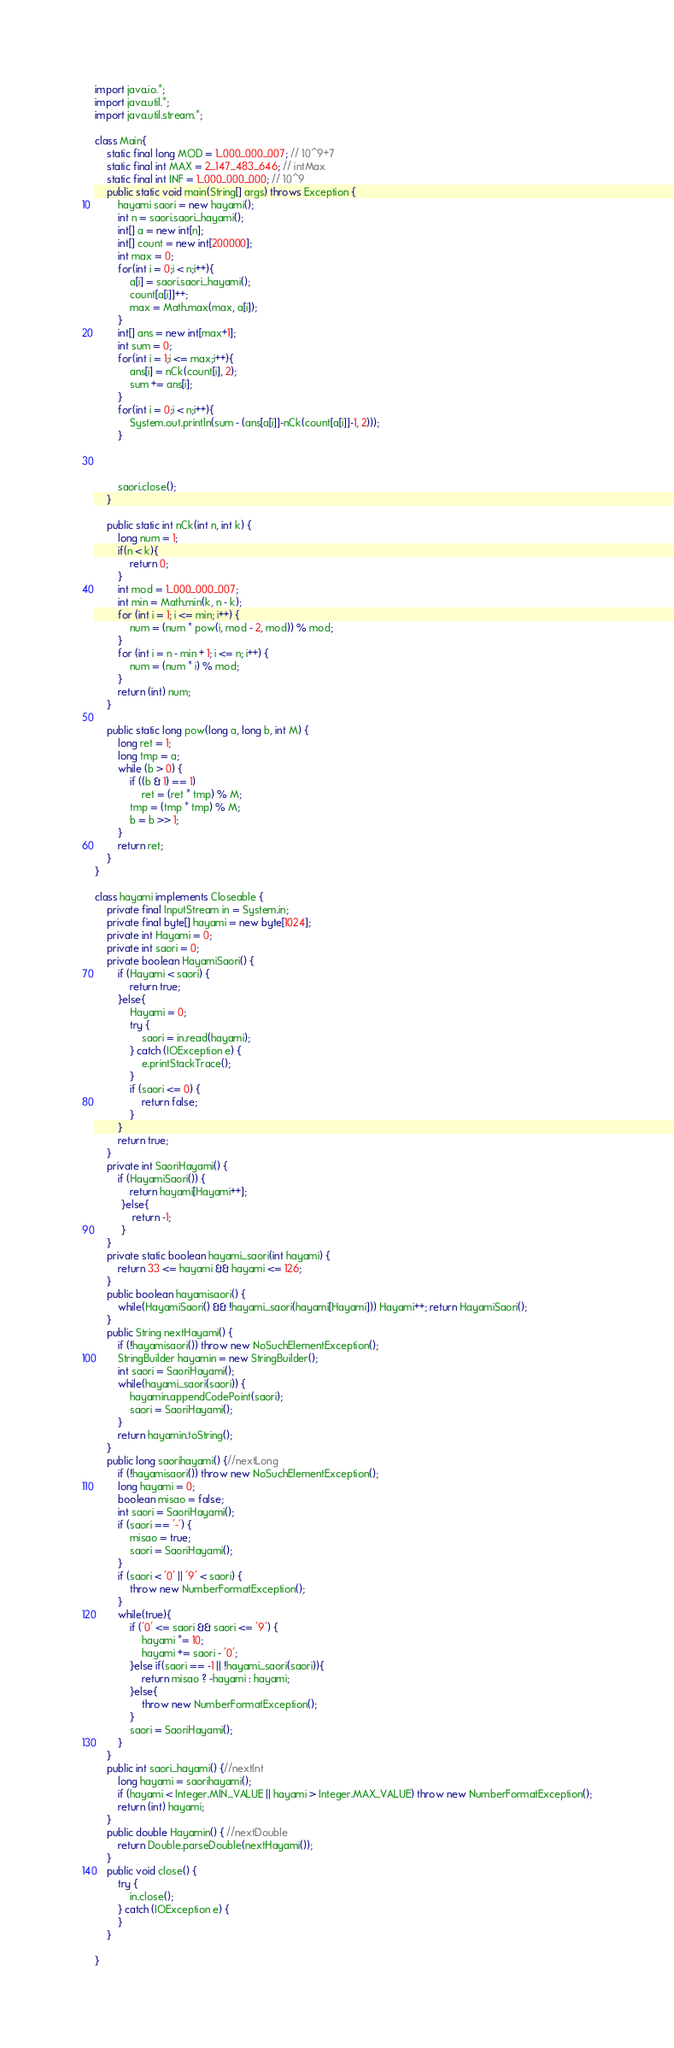<code> <loc_0><loc_0><loc_500><loc_500><_Java_>import java.io.*;
import java.util.*;
import java.util.stream.*;

class Main{
	static final long MOD = 1_000_000_007; // 10^9+7
    static final int MAX = 2_147_483_646; // intMax 
    static final int INF = 1_000_000_000; // 10^9  
    public static void main(String[] args) throws Exception {
		hayami saori = new hayami();
		int n = saori.saori_hayami();
		int[] a = new int[n];
		int[] count = new int[200000];
		int max = 0;
		for(int i = 0;i < n;i++){
			a[i] = saori.saori_hayami();
			count[a[i]]++;
			max = Math.max(max, a[i]);
		}
		int[] ans = new int[max+1];
		int sum = 0;
		for(int i = 1;i <= max;i++){
			ans[i] = nCk(count[i], 2);
			sum += ans[i];
		}
		for(int i = 0;i < n;i++){
			System.out.println(sum - (ans[a[i]]-nCk(count[a[i]]-1, 2)));
		}

		
		
		saori.close();
	}
	
	public static int nCk(int n, int k) {
		long num = 1;
		if(n < k){
			return 0;
		}
		int mod = 1_000_000_007;
		int min = Math.min(k, n - k);
		for (int i = 1; i <= min; i++) {
			num = (num * pow(i, mod - 2, mod)) % mod;
		}
		for (int i = n - min + 1; i <= n; i++) {
			num = (num * i) % mod;
		}
		return (int) num;
    }
    
    public static long pow(long a, long b, int M) {
		long ret = 1;
		long tmp = a;
		while (b > 0) {
			if ((b & 1) == 1)
				ret = (ret * tmp) % M;
			tmp = (tmp * tmp) % M;
			b = b >> 1;
		}
		return ret;
	}
}

class hayami implements Closeable {
	private final InputStream in = System.in;
	private final byte[] hayami = new byte[1024];
	private int Hayami = 0;
	private int saori = 0;
	private boolean HayamiSaori() {
		if (Hayami < saori) {
			return true;
		}else{
			Hayami = 0;
			try {
				saori = in.read(hayami);
			} catch (IOException e) {
				e.printStackTrace();
			}
			if (saori <= 0) {
				return false;
			}
		}
		return true;
	}
	private int SaoriHayami() { 
		if (HayamiSaori()) {
            return hayami[Hayami++];
         }else{
             return -1;
         }
	}
	private static boolean hayami_saori(int hayami) { 
		return 33 <= hayami && hayami <= 126;
	}
	public boolean hayamisaori() { 
		while(HayamiSaori() && !hayami_saori(hayami[Hayami])) Hayami++; return HayamiSaori();
	}
	public String nextHayami() {
		if (!hayamisaori()) throw new NoSuchElementException();
		StringBuilder hayamin = new StringBuilder();
		int saori = SaoriHayami();
		while(hayami_saori(saori)) {
			hayamin.appendCodePoint(saori);
			saori = SaoriHayami();
		}
		return hayamin.toString();
	}
	public long saorihayami() {//nextLong
		if (!hayamisaori()) throw new NoSuchElementException();
		long hayami = 0;
		boolean misao = false;
		int saori = SaoriHayami();
		if (saori == '-') {
			misao = true;
			saori = SaoriHayami();
		}
		if (saori < '0' || '9' < saori) {
			throw new NumberFormatException();
		}
		while(true){
			if ('0' <= saori && saori <= '9') {
				hayami *= 10;
				hayami += saori - '0';
			}else if(saori == -1 || !hayami_saori(saori)){
				return misao ? -hayami : hayami;
			}else{
				throw new NumberFormatException();
			}
			saori = SaoriHayami();
		}
	}
	public int saori_hayami() {//nextInt
		long hayami = saorihayami();
		if (hayami < Integer.MIN_VALUE || hayami > Integer.MAX_VALUE) throw new NumberFormatException();
		return (int) hayami;
	}
	public double Hayamin() { //nextDouble
		return Double.parseDouble(nextHayami());
	}
	public void close() {
		try {
			in.close();
		} catch (IOException e) {
		}
    }
    
}</code> 